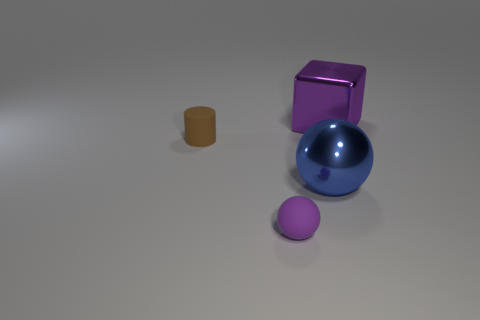What is the material of the small thing that is in front of the tiny thing behind the big shiny object that is in front of the large purple object?
Your answer should be very brief. Rubber. Are there fewer yellow matte things than shiny things?
Make the answer very short. Yes. Are the big purple block and the blue sphere made of the same material?
Provide a short and direct response. Yes. The matte thing that is the same color as the cube is what shape?
Your answer should be compact. Sphere. Does the object behind the brown cylinder have the same color as the large ball?
Provide a short and direct response. No. What number of purple shiny cubes are right of the purple object that is behind the tiny purple rubber thing?
Your answer should be very brief. 0. There is a sphere that is the same size as the brown rubber object; what color is it?
Ensure brevity in your answer.  Purple. What is the material of the purple object to the right of the matte ball?
Keep it short and to the point. Metal. What is the material of the thing that is left of the big metal ball and in front of the brown rubber thing?
Your response must be concise. Rubber. Is the size of the purple object behind the purple rubber sphere the same as the small purple matte sphere?
Offer a very short reply. No. 